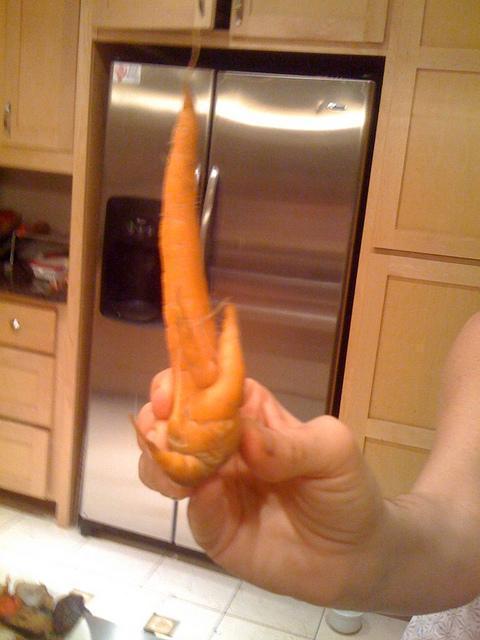What food category is this object in?
From the following set of four choices, select the accurate answer to respond to the question.
Options: Grain, fruit, vegetable, sweet. Vegetable. 